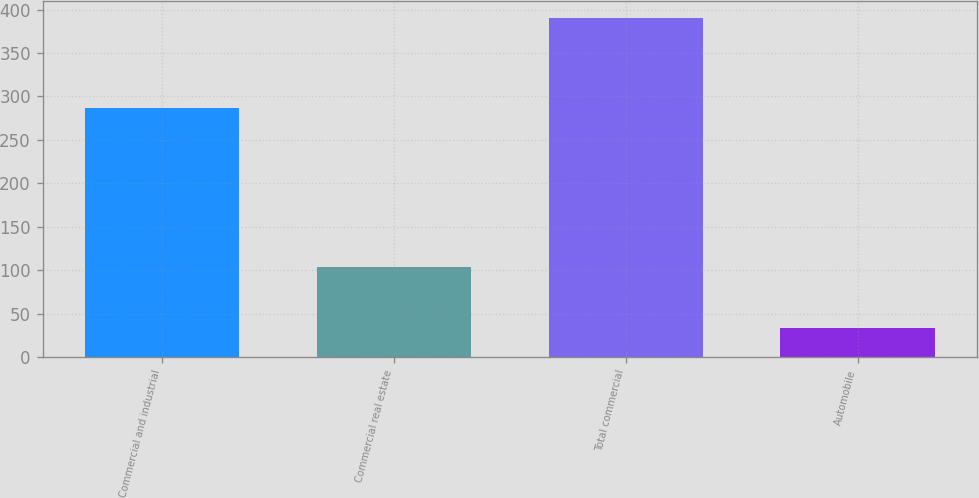Convert chart. <chart><loc_0><loc_0><loc_500><loc_500><bar_chart><fcel>Commercial and industrial<fcel>Commercial real estate<fcel>Total commercial<fcel>Automobile<nl><fcel>287<fcel>103<fcel>390<fcel>33<nl></chart> 